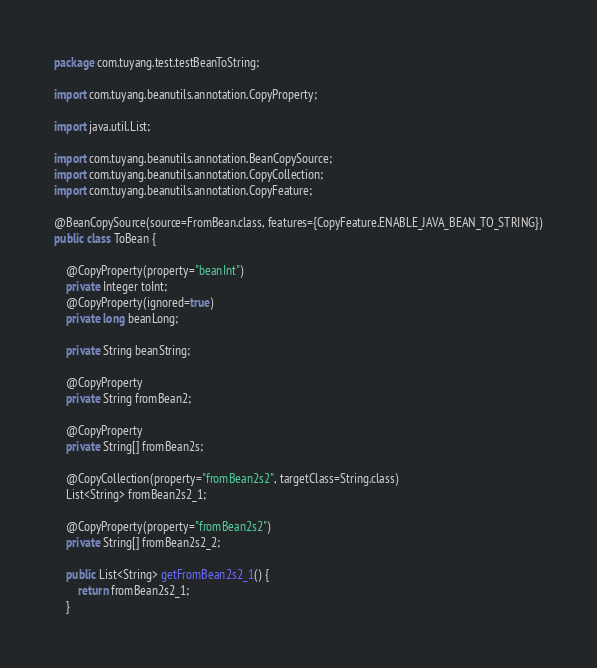Convert code to text. <code><loc_0><loc_0><loc_500><loc_500><_Java_>package com.tuyang.test.testBeanToString;

import com.tuyang.beanutils.annotation.CopyProperty;

import java.util.List;

import com.tuyang.beanutils.annotation.BeanCopySource;
import com.tuyang.beanutils.annotation.CopyCollection;
import com.tuyang.beanutils.annotation.CopyFeature;

@BeanCopySource(source=FromBean.class, features={CopyFeature.ENABLE_JAVA_BEAN_TO_STRING})
public class ToBean {

	@CopyProperty(property="beanInt")
	private Integer toInt;
	@CopyProperty(ignored=true)
	private long beanLong;
	
	private String beanString;
	
	@CopyProperty
	private String fromBean2;
	
	@CopyProperty
	private String[] fromBean2s;
	
	@CopyCollection(property="fromBean2s2", targetClass=String.class)
	List<String> fromBean2s2_1;
	
	@CopyProperty(property="fromBean2s2")
	private String[] fromBean2s2_2;

	public List<String> getFromBean2s2_1() {
		return fromBean2s2_1;
	}
</code> 